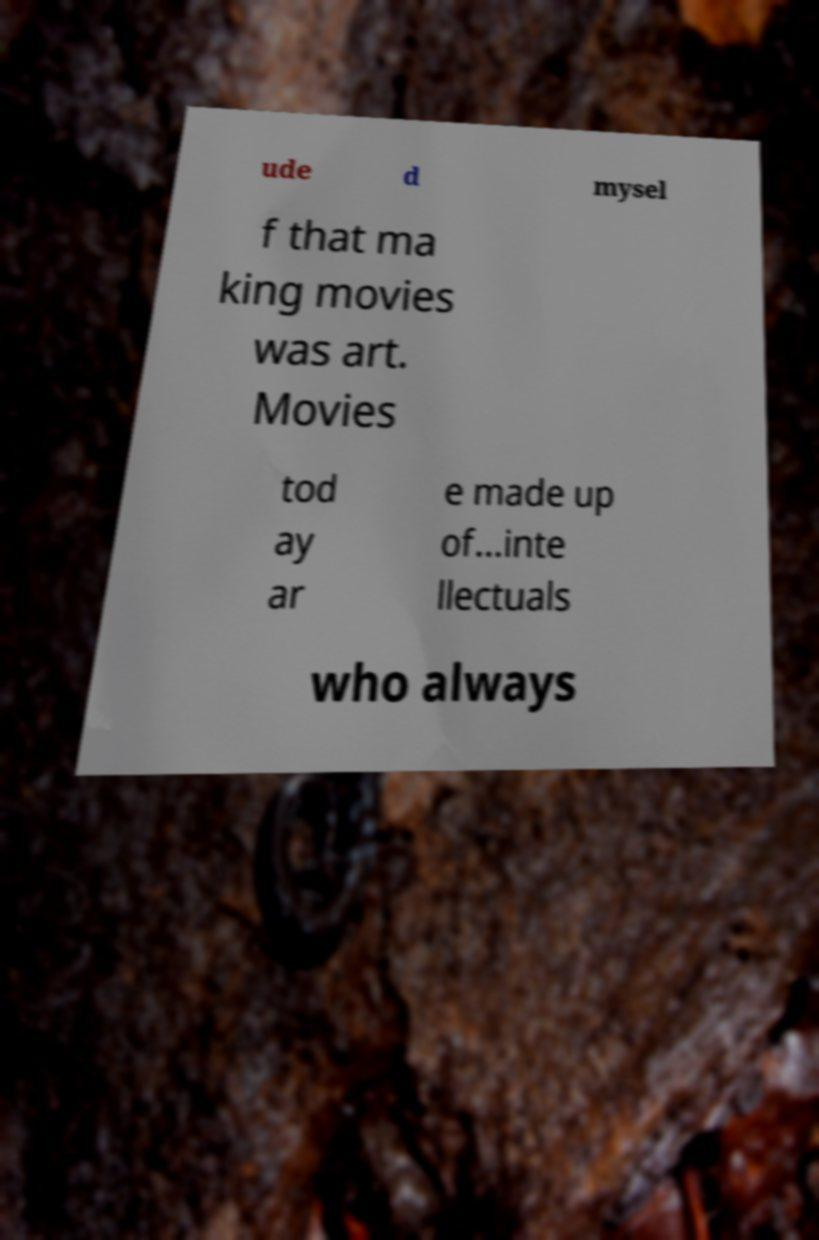Can you accurately transcribe the text from the provided image for me? ude d mysel f that ma king movies was art. Movies tod ay ar e made up of…inte llectuals who always 